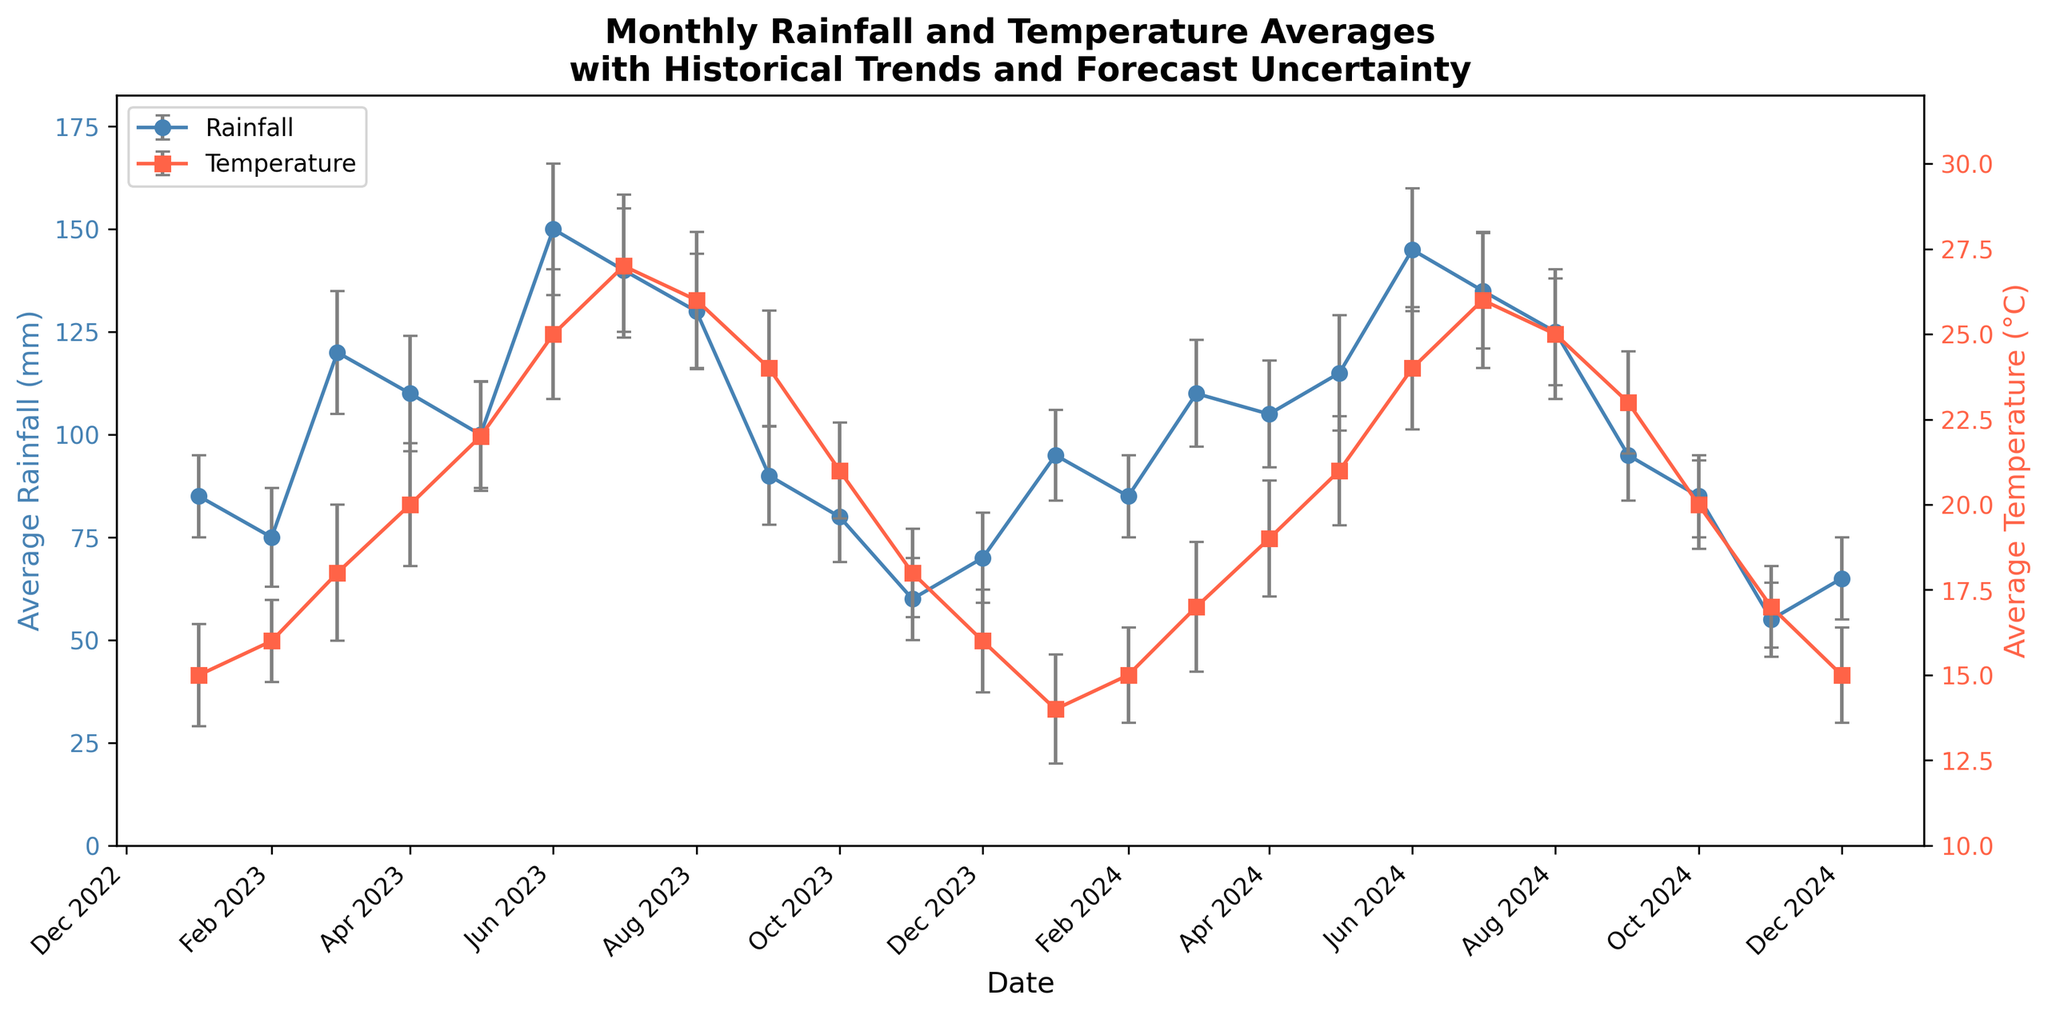What is the title of the figure? The title of the figure is displayed at the top of the chart. It helps to identify the content of the figure.
Answer: Monthly Rainfall and Temperature Averages with Historical Trends and Forecast Uncertainty What are the two variables plotted on the y-axes? The y-axes label indicates the two variables measured. On the left y-axis, it shows Average Rainfall in millimeters. On the right y-axis, it shows Average Temperature in degrees Celsius.
Answer: Average Rainfall (mm) and Average Temperature (°C) What month and year recorded the highest average rainfall? To find the highest average rainfall, look at the peaks in the rainfall line (blue color) and identify the corresponding month and year on the x-axis.
Answer: June 2023 In which month and year does the average temperature reach its peak in 2024? Observe the red line representing temperature and find the highest peak point within the year 2024.
Answer: July 2024 How does the average rainfall in December 2023 compare to December 2024? To make the comparison, locate December 2023 and December 2024 on the x-axis and compare the heights of the blue lines at those points.
Answer: Higher in December 2023 What is the average temperature for March 2024? Find March 2024 on the x-axis and follow the red line to the corresponding y-value. The error bars can be disregarded for this specific value.
Answer: 17°C Which month in 2024 has the minimum average rainfall? To find the minimum average rainfall in 2024, identify the lowest blue line point within that year and note the corresponding month on the x-axis.
Answer: November 2024 What is the uncertainty in the average temperature for June 2023? The uncertainty is represented by the length of the error bars above and below the data point for June 2023 in the red line. Check the error bar length to determine the uncertainty.
Answer: ±1.9°C Calculate the difference in average rainfall between July 2024 and July 2023. Locate July 2023 and July 2024 on the x-axis, find their corresponding average rainfall values, and subtract the value of July 2023 from July 2024.
Answer: 135 mm - 140 mm = -5 mm Does the average temperature tend to increase or decrease from January to July in 2023? Follow the red temperature line from January 2023 to July 2023 to see the trend. Determine if the line generally slopes upwards or downwards.
Answer: Increase 